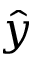Convert formula to latex. <formula><loc_0><loc_0><loc_500><loc_500>\hat { y }</formula> 